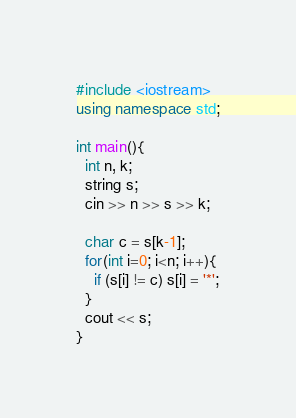<code> <loc_0><loc_0><loc_500><loc_500><_C++_>#include <iostream>
using namespace std;

int main(){
  int n, k;
  string s;
  cin >> n >> s >> k;
  
  char c = s[k-1];
  for(int i=0; i<n; i++){
    if (s[i] != c) s[i] = '*';
  }
  cout << s;
}</code> 